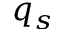<formula> <loc_0><loc_0><loc_500><loc_500>q _ { s }</formula> 